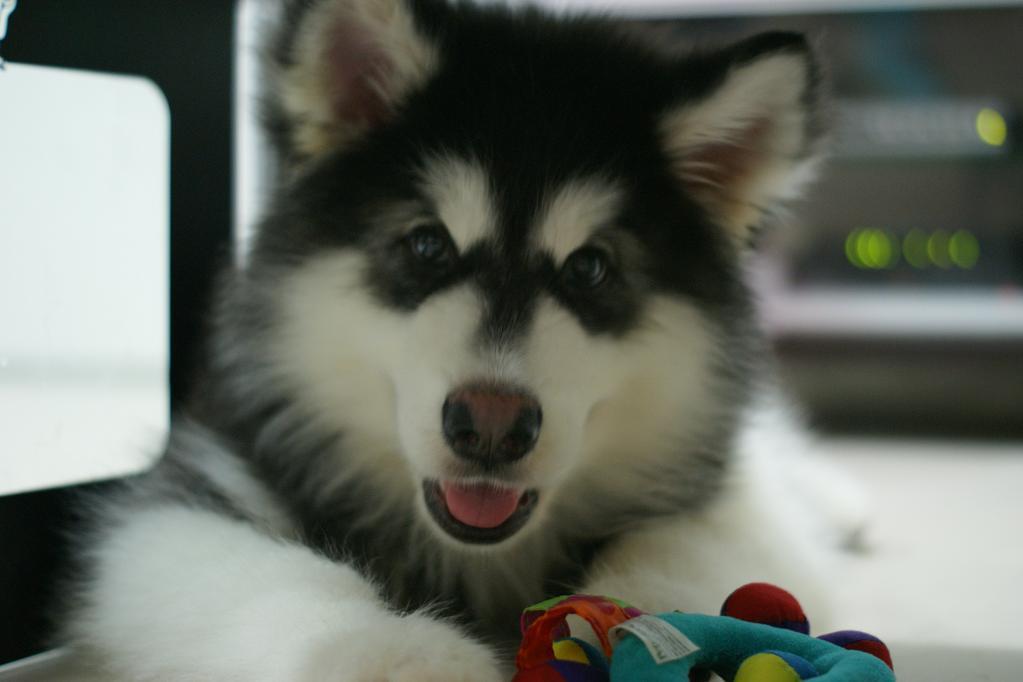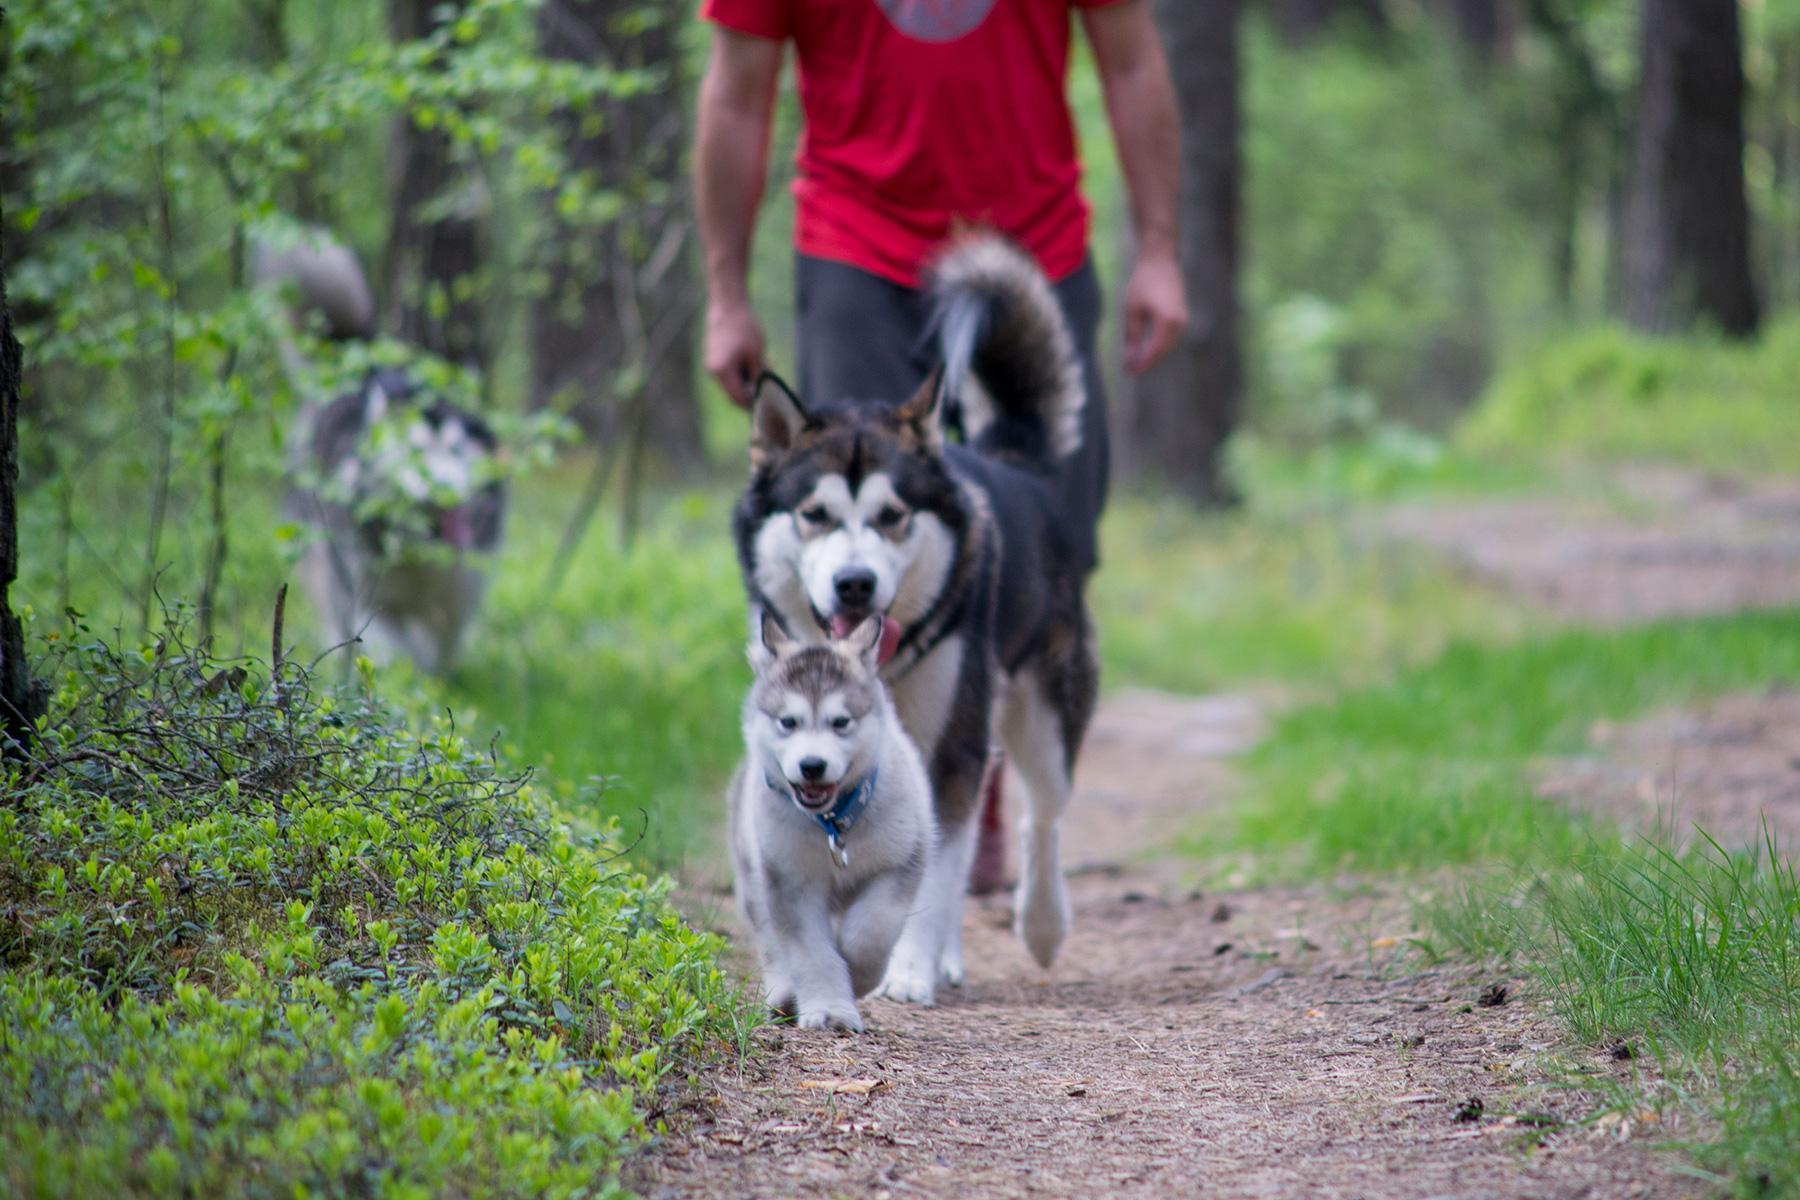The first image is the image on the left, the second image is the image on the right. For the images shown, is this caption "There are less than 4 dogs" true? Answer yes or no. No. The first image is the image on the left, the second image is the image on the right. For the images shown, is this caption "The right image contains at least two dogs." true? Answer yes or no. Yes. 